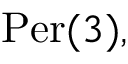<formula> <loc_0><loc_0><loc_500><loc_500>{ P e r } ( 3 ) ,</formula> 